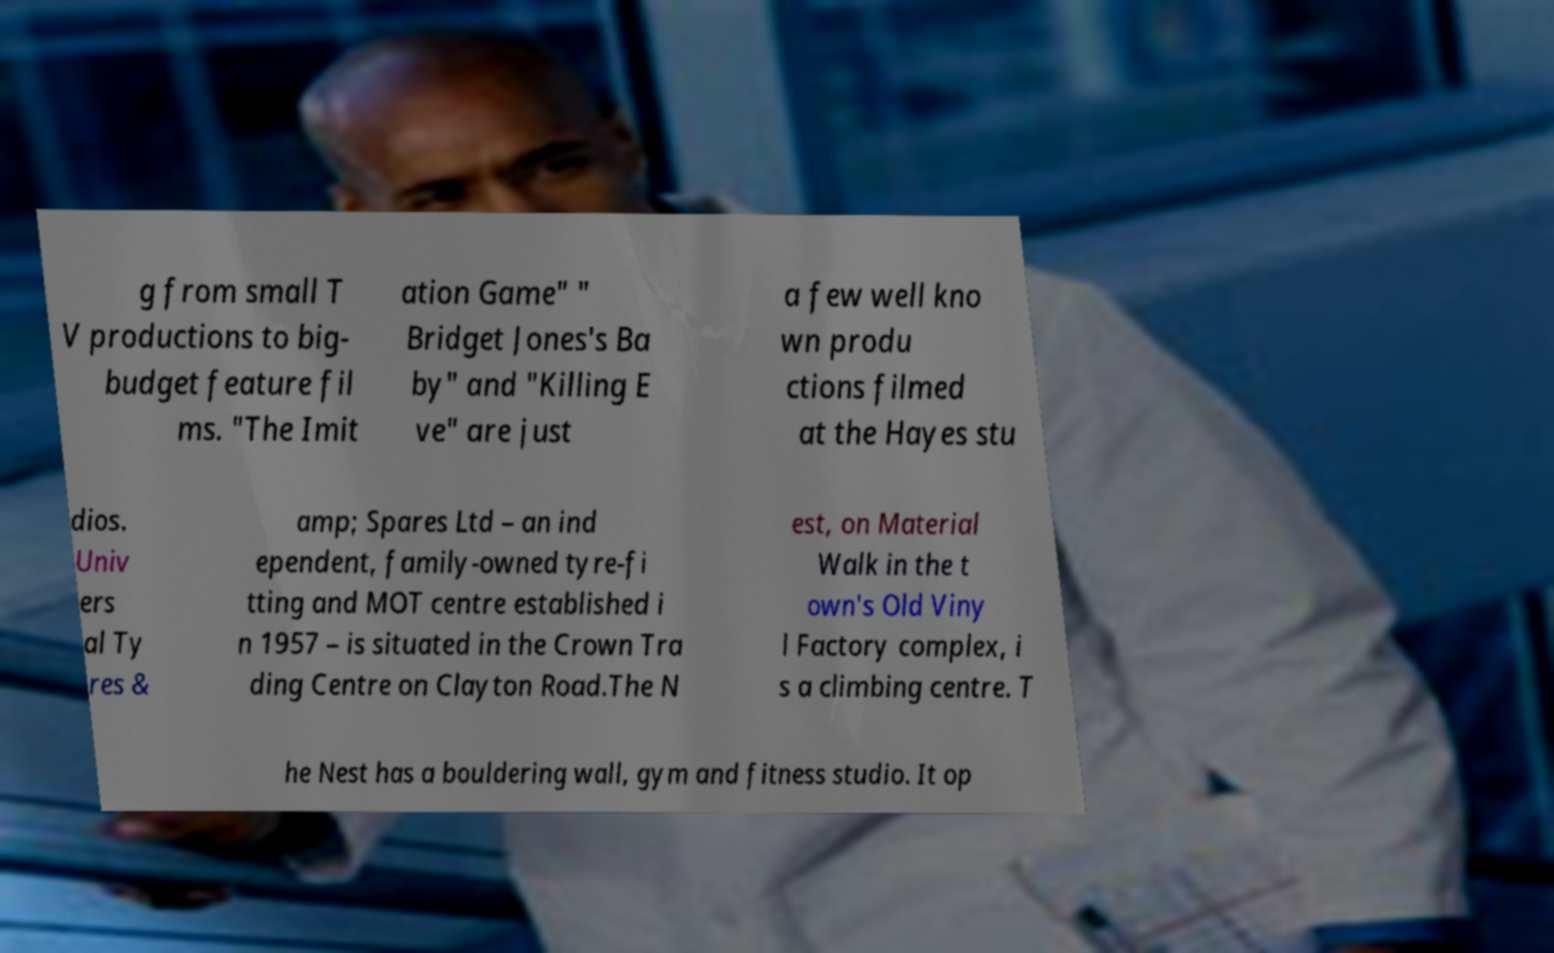Please identify and transcribe the text found in this image. g from small T V productions to big- budget feature fil ms. "The Imit ation Game" " Bridget Jones's Ba by" and "Killing E ve" are just a few well kno wn produ ctions filmed at the Hayes stu dios. Univ ers al Ty res & amp; Spares Ltd – an ind ependent, family-owned tyre-fi tting and MOT centre established i n 1957 – is situated in the Crown Tra ding Centre on Clayton Road.The N est, on Material Walk in the t own's Old Viny l Factory complex, i s a climbing centre. T he Nest has a bouldering wall, gym and fitness studio. It op 